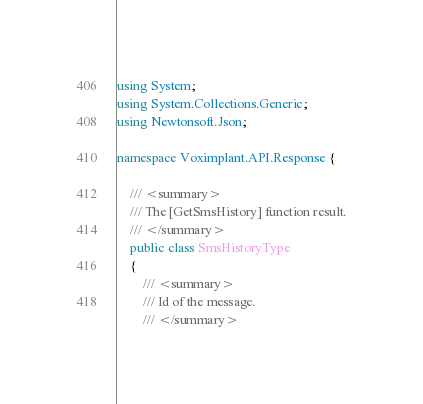Convert code to text. <code><loc_0><loc_0><loc_500><loc_500><_C#_>using System;
using System.Collections.Generic;
using Newtonsoft.Json;

namespace Voximplant.API.Response {

    /// <summary>
    /// The [GetSmsHistory] function result.
    /// </summary>
    public class SmsHistoryType
    {
        /// <summary>
        /// Id of the message.
        /// </summary></code> 